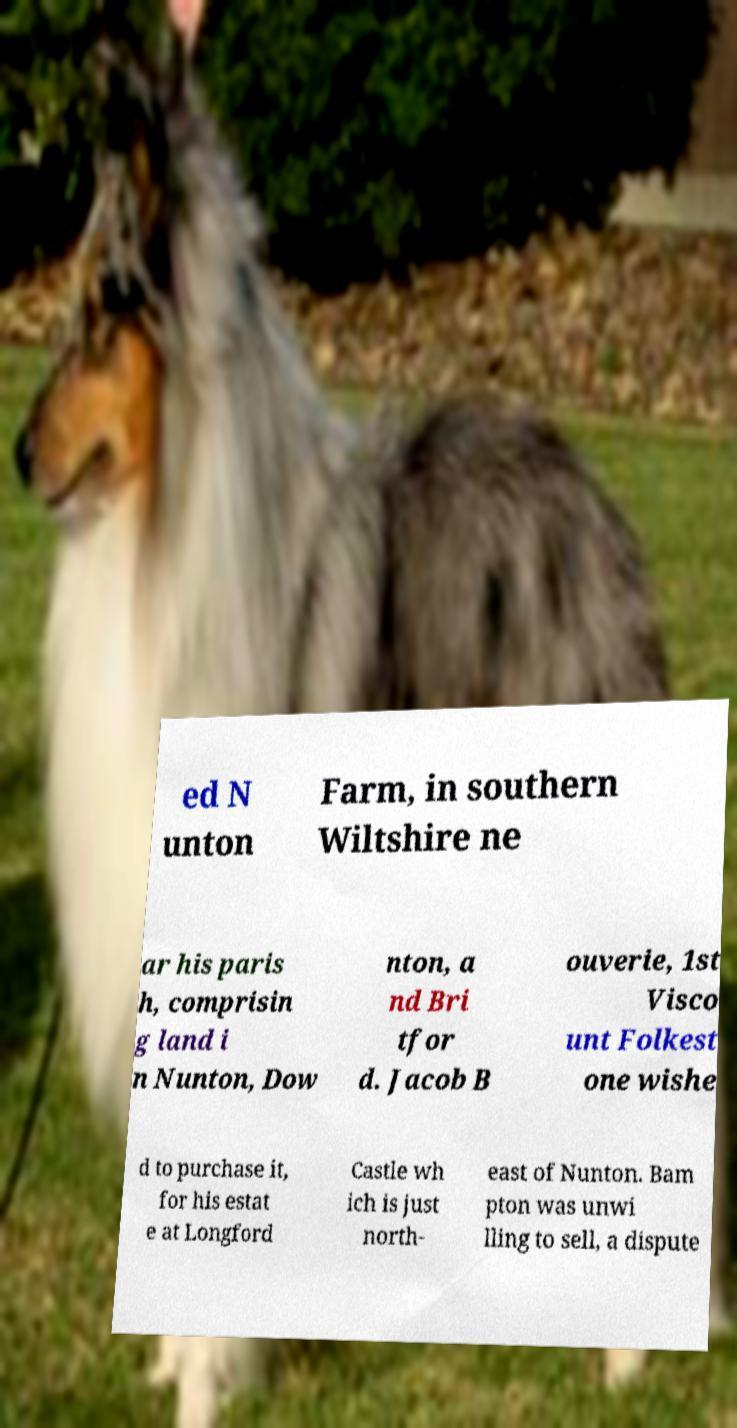Please read and relay the text visible in this image. What does it say? ed N unton Farm, in southern Wiltshire ne ar his paris h, comprisin g land i n Nunton, Dow nton, a nd Bri tfor d. Jacob B ouverie, 1st Visco unt Folkest one wishe d to purchase it, for his estat e at Longford Castle wh ich is just north- east of Nunton. Bam pton was unwi lling to sell, a dispute 